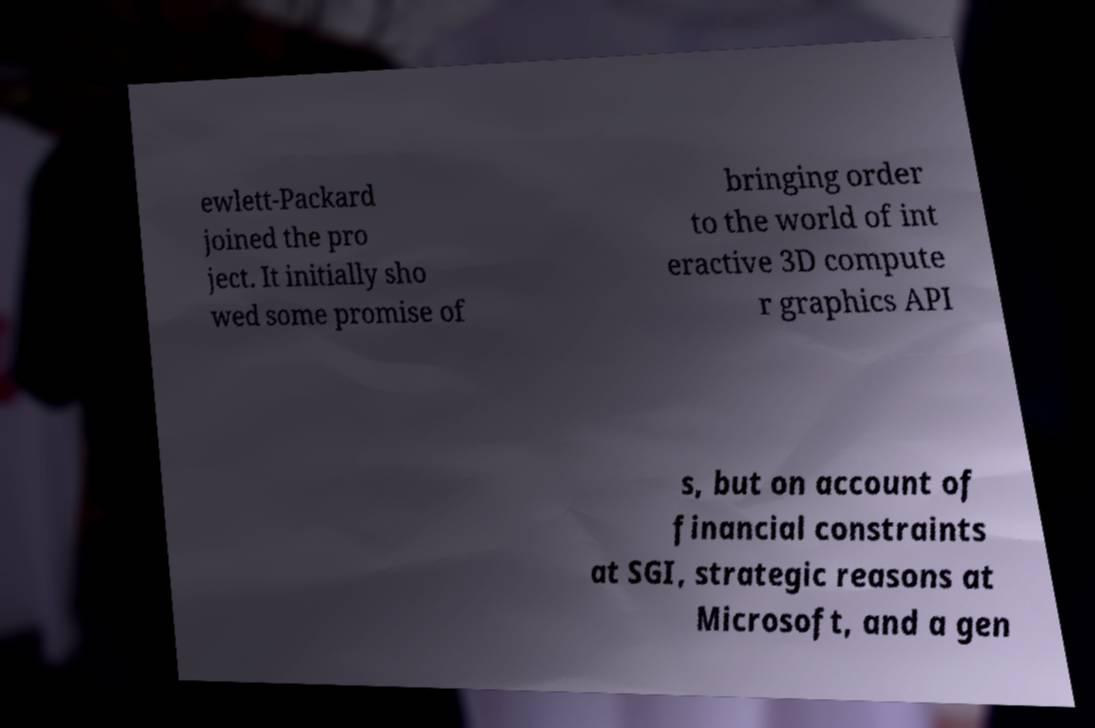Could you extract and type out the text from this image? ewlett-Packard joined the pro ject. It initially sho wed some promise of bringing order to the world of int eractive 3D compute r graphics API s, but on account of financial constraints at SGI, strategic reasons at Microsoft, and a gen 